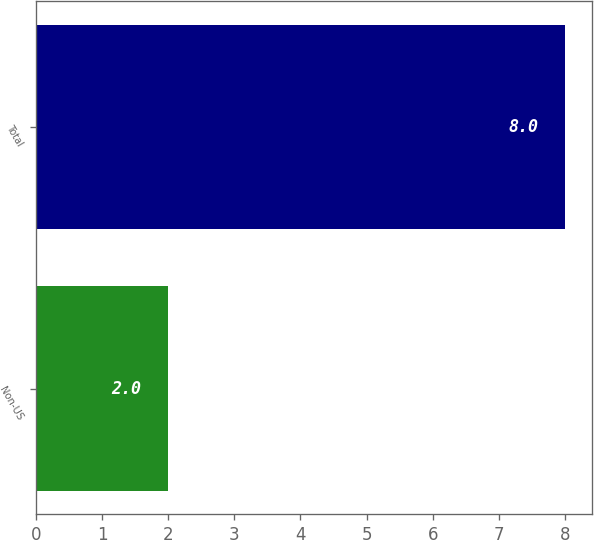<chart> <loc_0><loc_0><loc_500><loc_500><bar_chart><fcel>Non-US<fcel>Total<nl><fcel>2<fcel>8<nl></chart> 